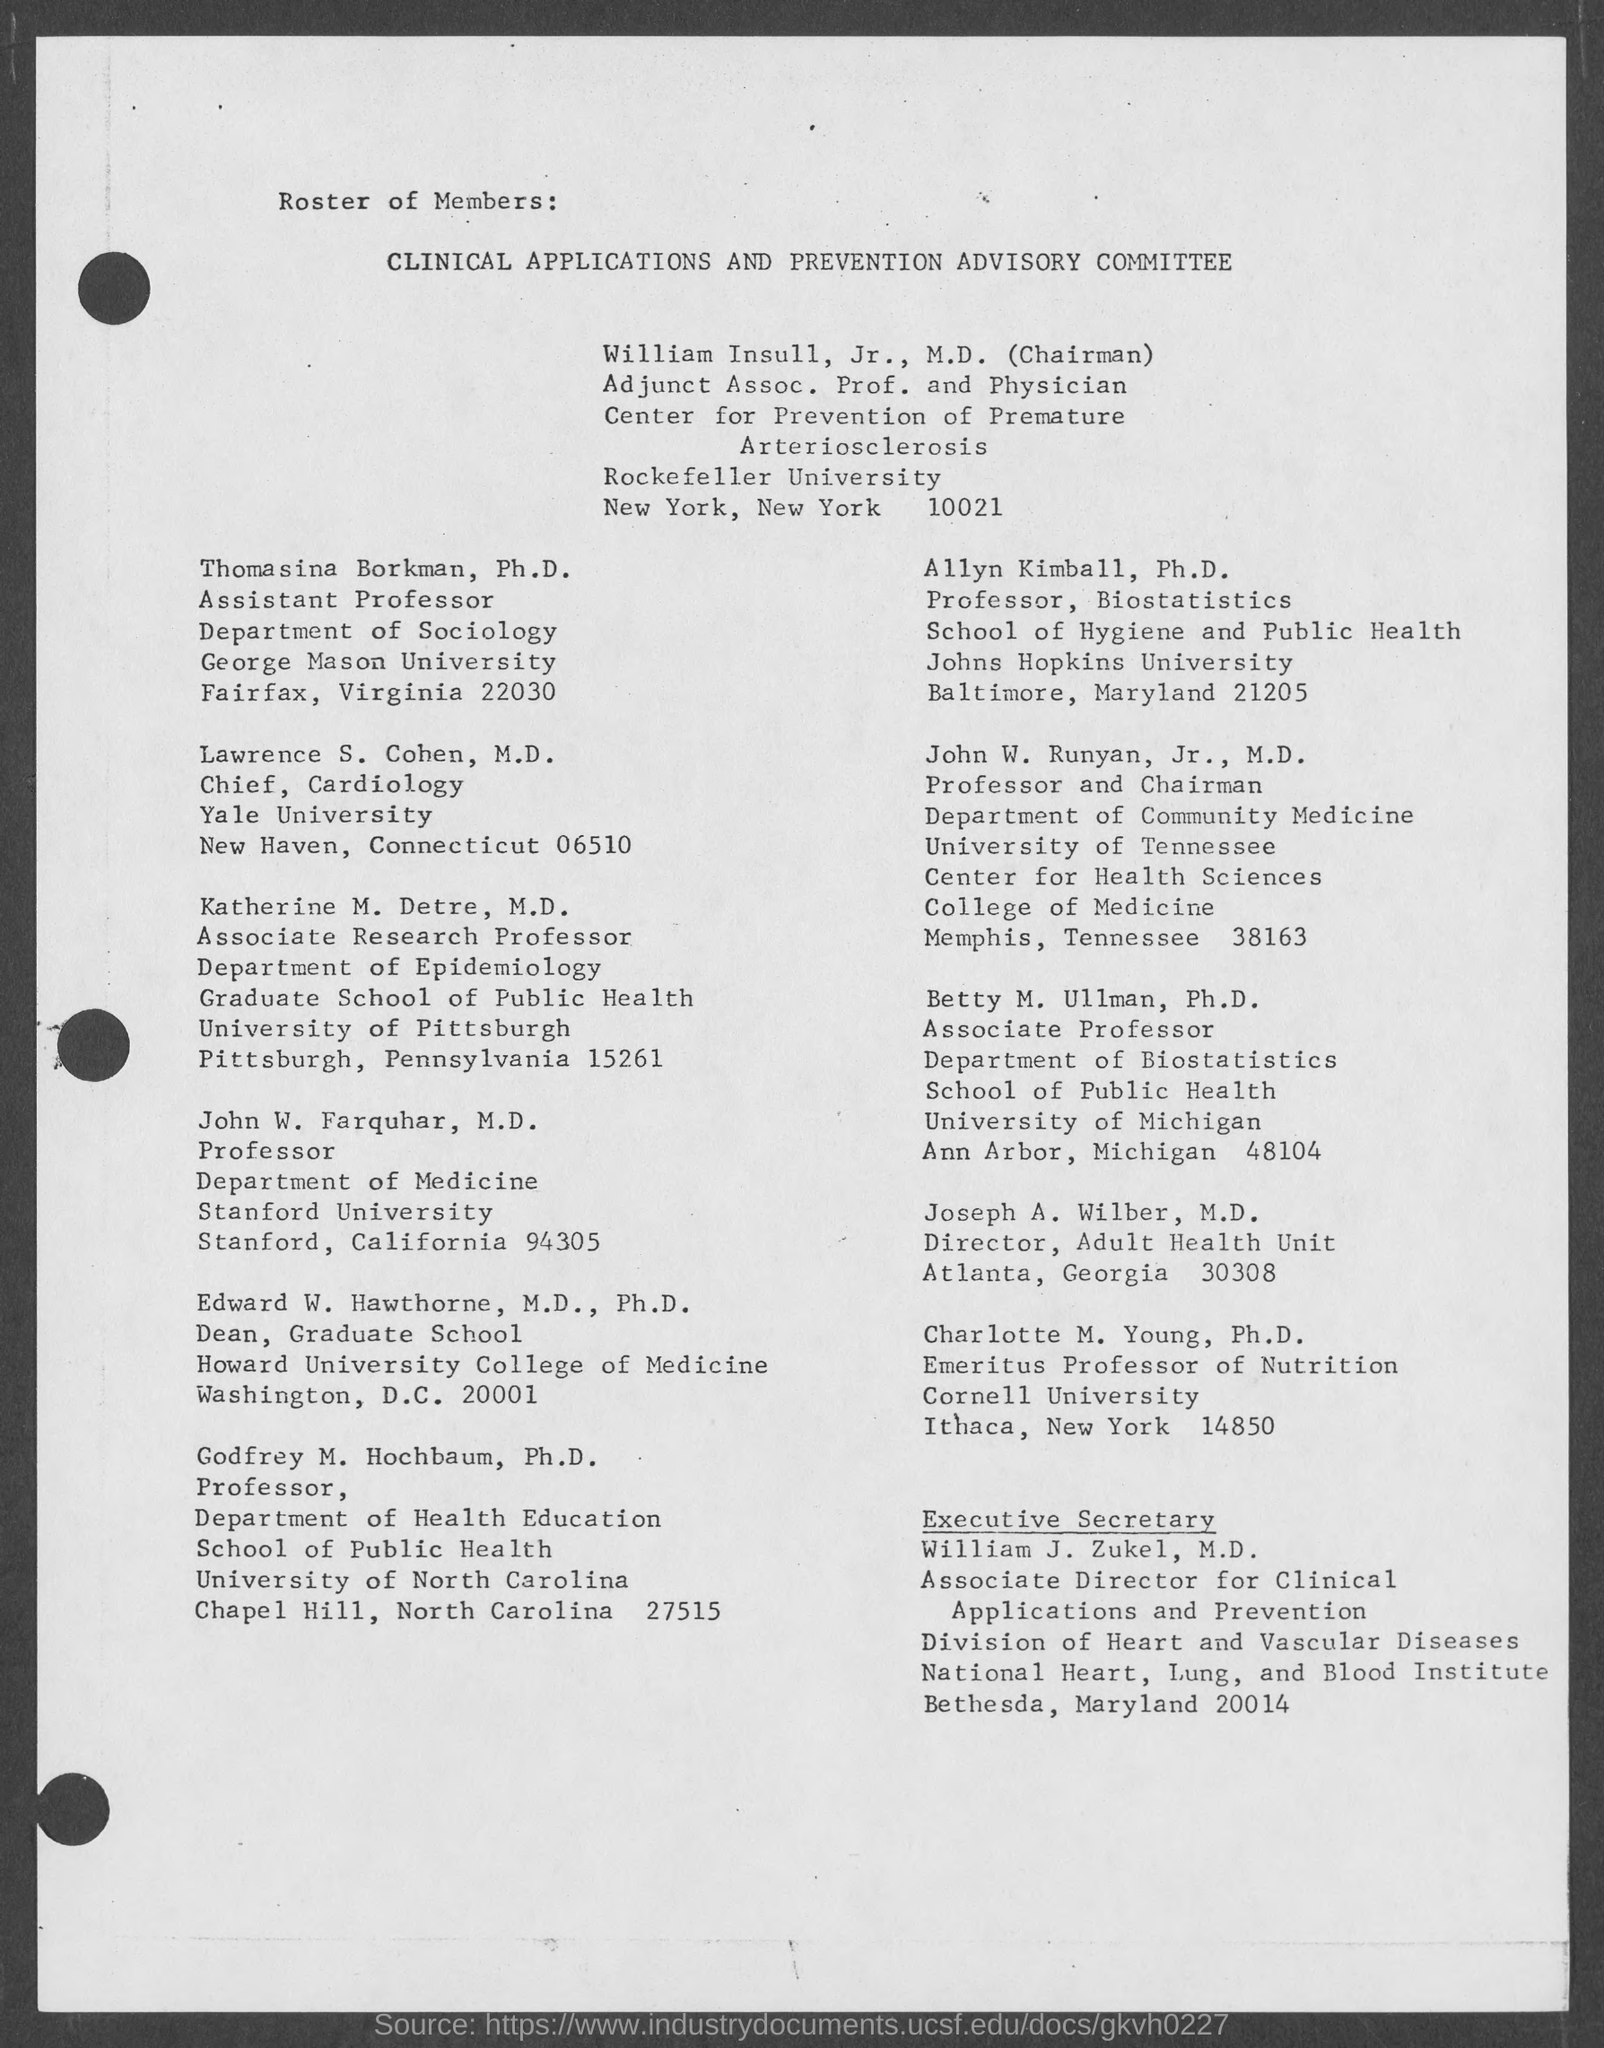Who is the Chairman of Clinical Applications and Prevention Advisory Committee?
Give a very brief answer. William  Insull, Jr., M.D. Who is the Chief of Cardiology, Yale University?
Give a very brief answer. Lawrence S. Cohen, M.D. Who is the executive secretary of Clinical Applications and Prevention Advisory Committee?
Your response must be concise. William J. Zukel, M.D. 